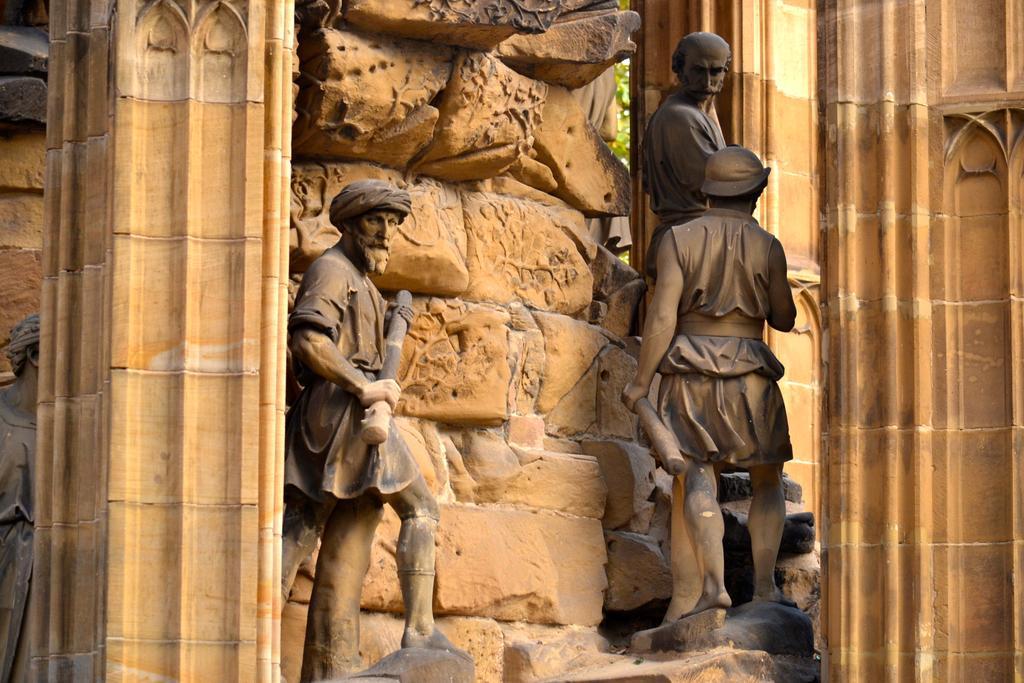How would you summarize this image in a sentence or two? In this image, I can see the sculptures of three people standing. These look like the rocks. I can see the pillars. On the left side of the image, here is another sculpture, which is behind the pillar. 